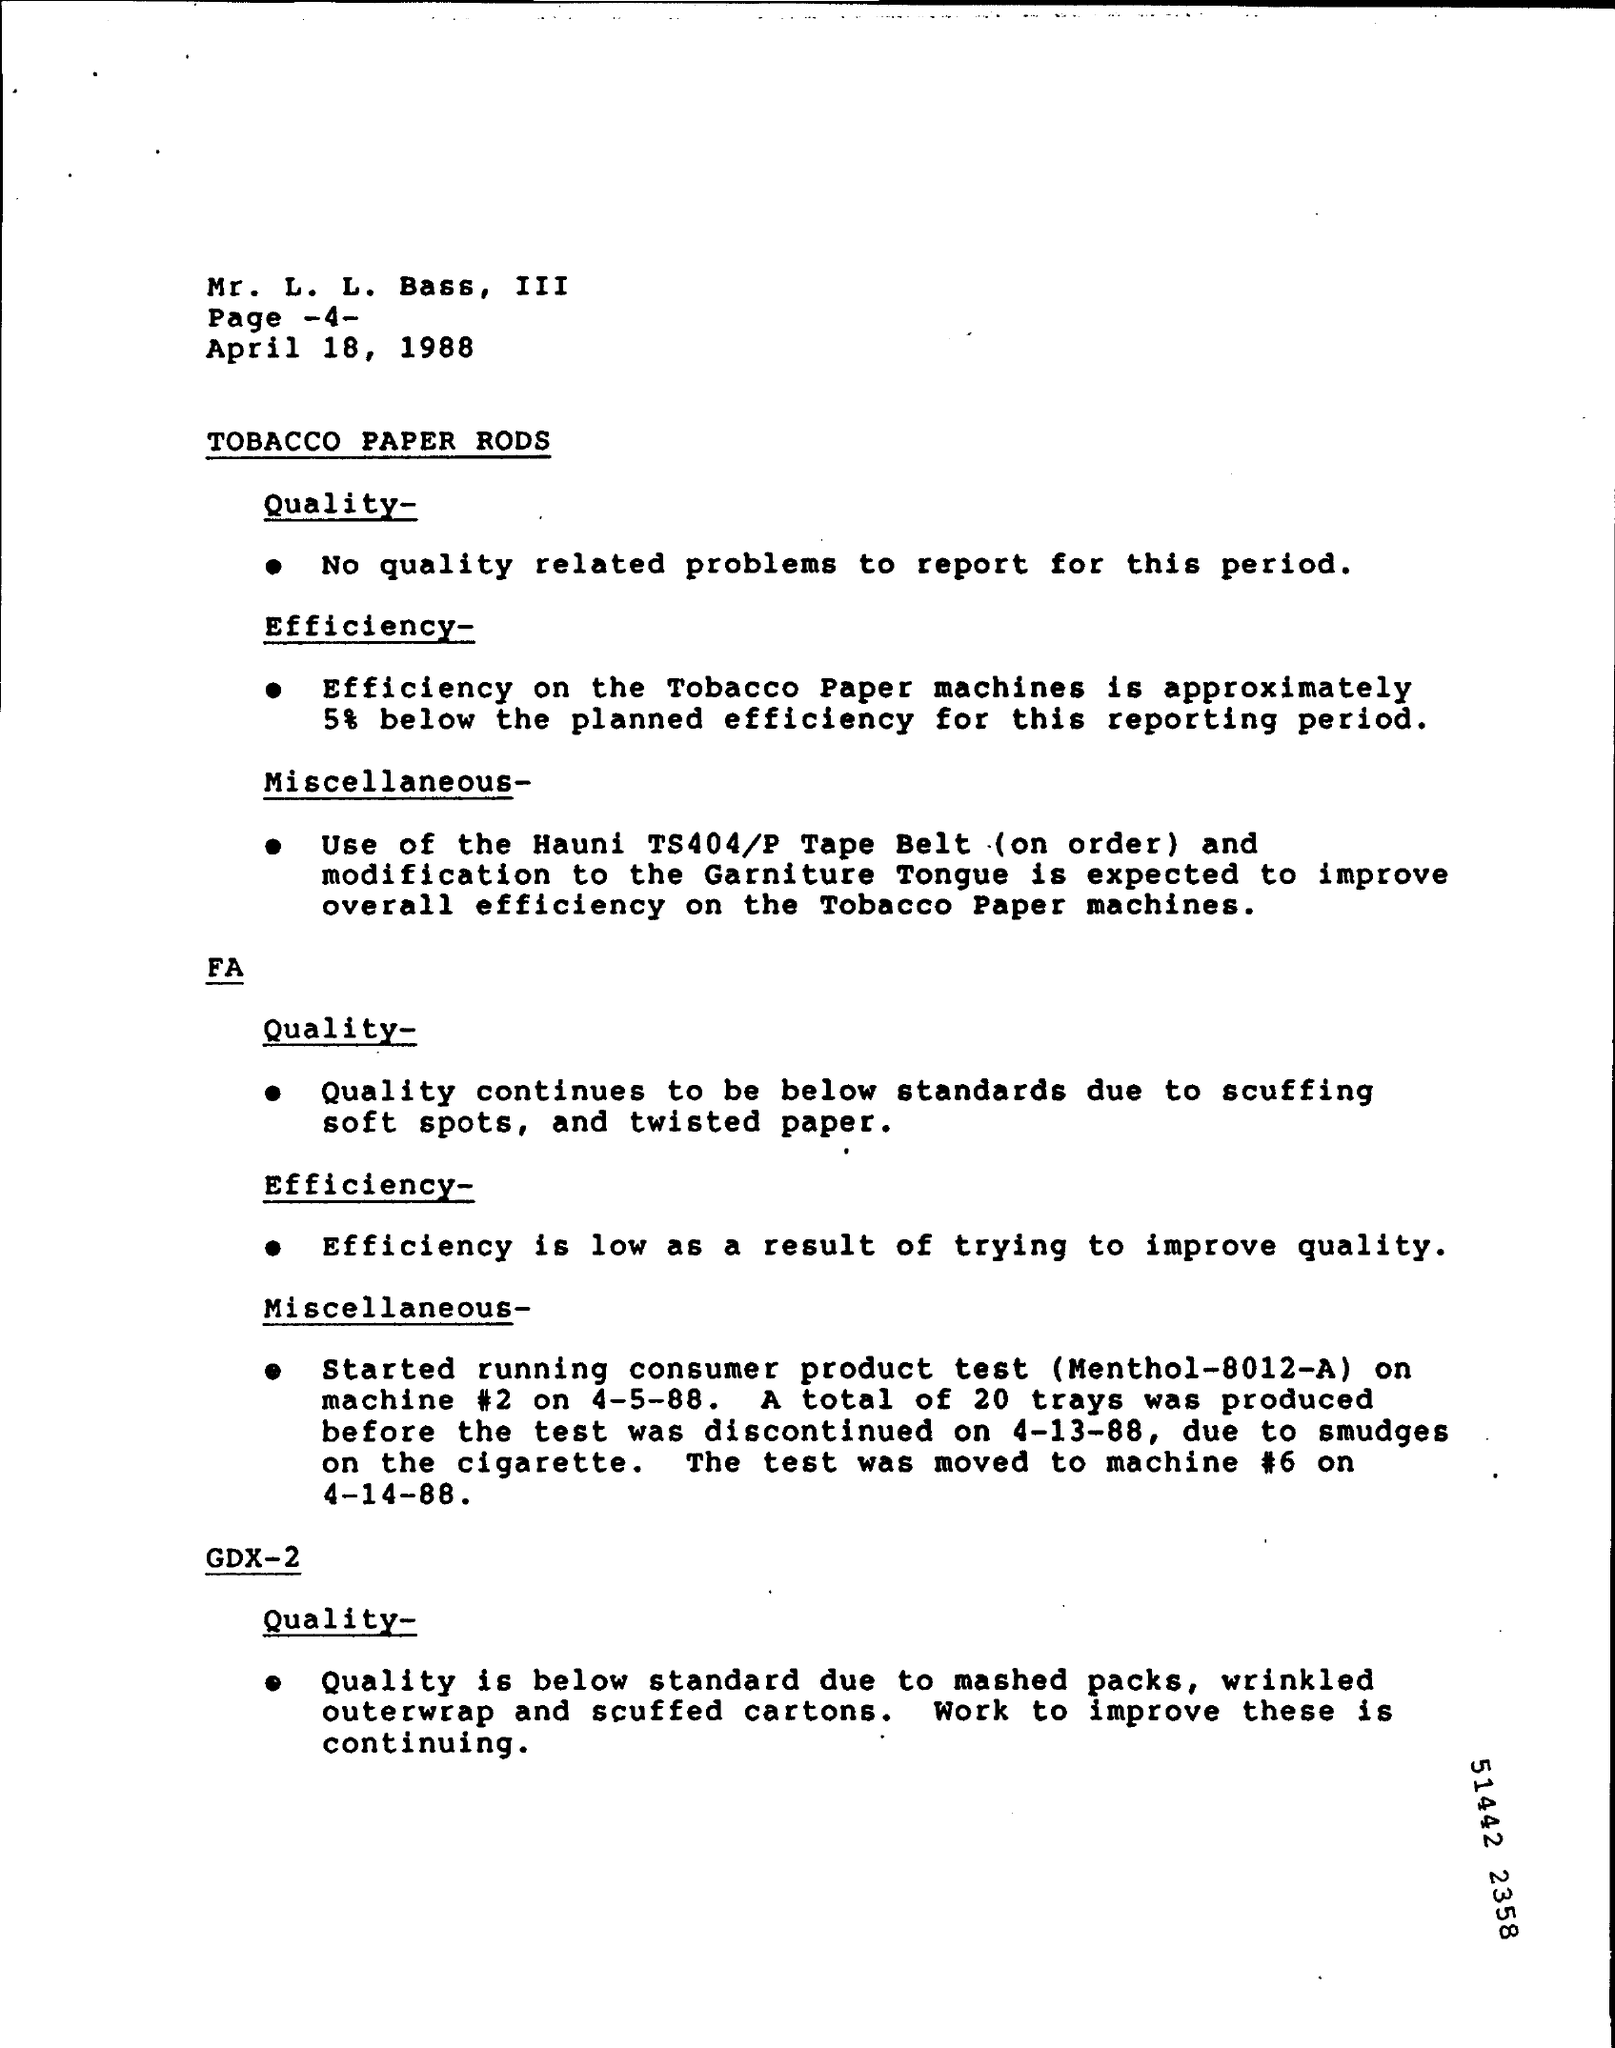Identify some key points in this picture. Efficiency is low due to what results in an effort to improve quality. The page number mentioned is -4-. The test was moved to machine #6 on April 14, 1988. 